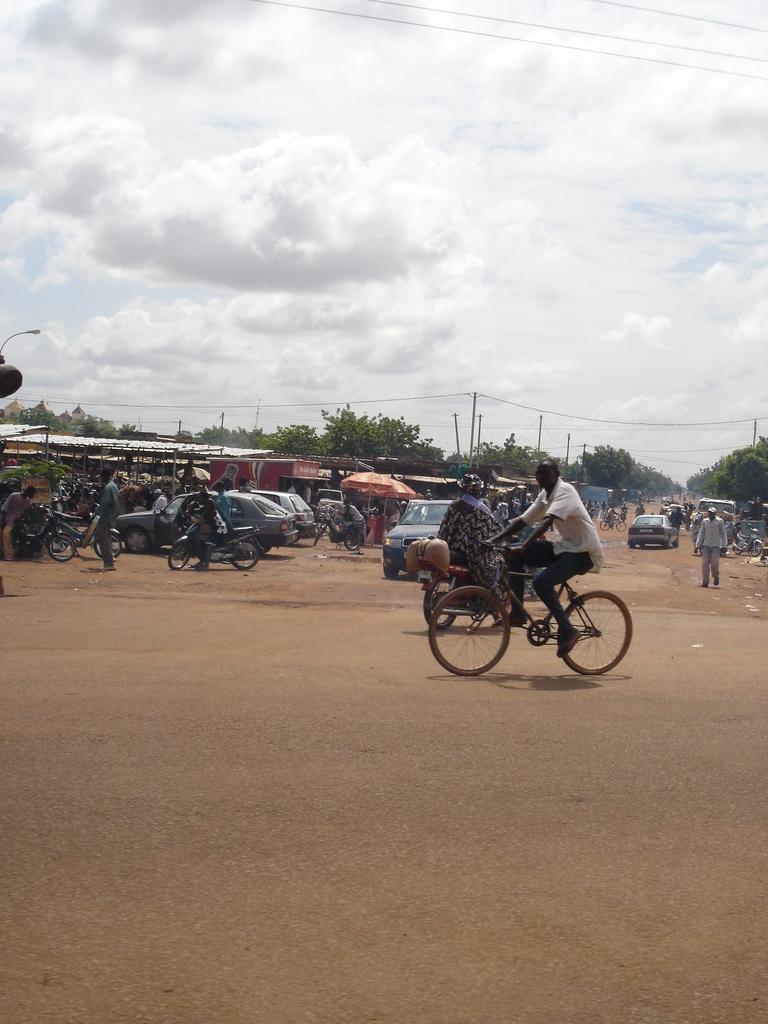Could you give a brief overview of what you see in this image? This picture is clicked on the road. In the center of the image there is a riding bicycle. On the left corner of the image there are vehicles parked. Behind them there are some sheds. There are trees and poles in the image. On the top of the image there is a cloudy sky. On the right corner of the image there is a person is walking. 